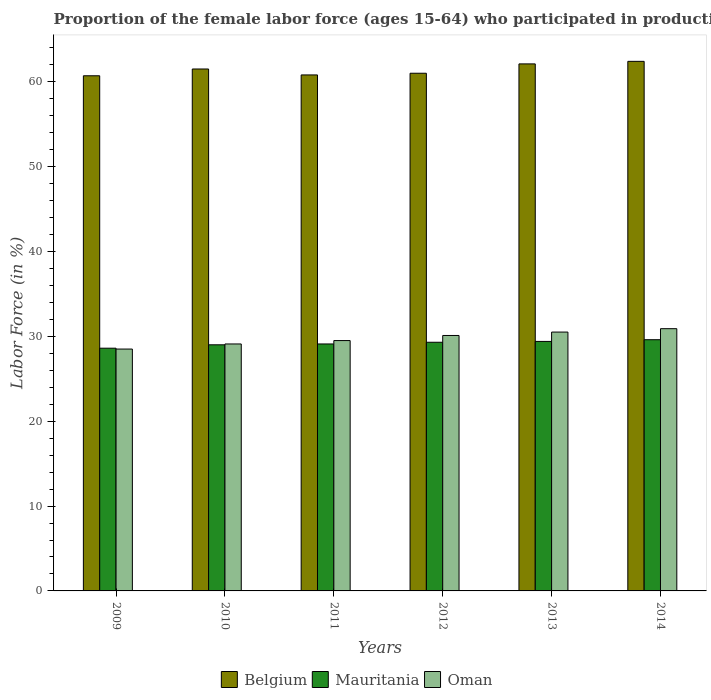How many bars are there on the 1st tick from the left?
Give a very brief answer. 3. What is the label of the 1st group of bars from the left?
Provide a short and direct response. 2009. What is the proportion of the female labor force who participated in production in Oman in 2011?
Give a very brief answer. 29.5. Across all years, what is the maximum proportion of the female labor force who participated in production in Oman?
Your answer should be very brief. 30.9. Across all years, what is the minimum proportion of the female labor force who participated in production in Belgium?
Provide a short and direct response. 60.7. What is the total proportion of the female labor force who participated in production in Oman in the graph?
Provide a succinct answer. 178.6. What is the difference between the proportion of the female labor force who participated in production in Oman in 2010 and the proportion of the female labor force who participated in production in Belgium in 2012?
Your response must be concise. -31.9. What is the average proportion of the female labor force who participated in production in Mauritania per year?
Give a very brief answer. 29.17. In the year 2010, what is the difference between the proportion of the female labor force who participated in production in Mauritania and proportion of the female labor force who participated in production in Belgium?
Ensure brevity in your answer.  -32.5. In how many years, is the proportion of the female labor force who participated in production in Belgium greater than 24 %?
Keep it short and to the point. 6. What is the ratio of the proportion of the female labor force who participated in production in Mauritania in 2010 to that in 2011?
Provide a short and direct response. 1. Is the proportion of the female labor force who participated in production in Belgium in 2009 less than that in 2014?
Your response must be concise. Yes. Is the difference between the proportion of the female labor force who participated in production in Mauritania in 2012 and 2013 greater than the difference between the proportion of the female labor force who participated in production in Belgium in 2012 and 2013?
Offer a terse response. Yes. What is the difference between the highest and the second highest proportion of the female labor force who participated in production in Belgium?
Provide a succinct answer. 0.3. What is the difference between the highest and the lowest proportion of the female labor force who participated in production in Belgium?
Your answer should be compact. 1.7. In how many years, is the proportion of the female labor force who participated in production in Belgium greater than the average proportion of the female labor force who participated in production in Belgium taken over all years?
Make the answer very short. 3. What does the 1st bar from the left in 2009 represents?
Ensure brevity in your answer.  Belgium. Are all the bars in the graph horizontal?
Your response must be concise. No. What is the difference between two consecutive major ticks on the Y-axis?
Offer a terse response. 10. Are the values on the major ticks of Y-axis written in scientific E-notation?
Your answer should be compact. No. Does the graph contain grids?
Ensure brevity in your answer.  No. Where does the legend appear in the graph?
Offer a very short reply. Bottom center. How many legend labels are there?
Offer a very short reply. 3. What is the title of the graph?
Your answer should be very brief. Proportion of the female labor force (ages 15-64) who participated in production. Does "East Asia (developing only)" appear as one of the legend labels in the graph?
Your answer should be very brief. No. What is the Labor Force (in %) of Belgium in 2009?
Your answer should be very brief. 60.7. What is the Labor Force (in %) in Mauritania in 2009?
Give a very brief answer. 28.6. What is the Labor Force (in %) in Belgium in 2010?
Provide a succinct answer. 61.5. What is the Labor Force (in %) of Oman in 2010?
Offer a terse response. 29.1. What is the Labor Force (in %) of Belgium in 2011?
Give a very brief answer. 60.8. What is the Labor Force (in %) of Mauritania in 2011?
Offer a terse response. 29.1. What is the Labor Force (in %) of Oman in 2011?
Provide a succinct answer. 29.5. What is the Labor Force (in %) of Belgium in 2012?
Your answer should be very brief. 61. What is the Labor Force (in %) of Mauritania in 2012?
Keep it short and to the point. 29.3. What is the Labor Force (in %) in Oman in 2012?
Provide a short and direct response. 30.1. What is the Labor Force (in %) in Belgium in 2013?
Make the answer very short. 62.1. What is the Labor Force (in %) in Mauritania in 2013?
Your response must be concise. 29.4. What is the Labor Force (in %) of Oman in 2013?
Offer a terse response. 30.5. What is the Labor Force (in %) in Belgium in 2014?
Your answer should be very brief. 62.4. What is the Labor Force (in %) of Mauritania in 2014?
Ensure brevity in your answer.  29.6. What is the Labor Force (in %) of Oman in 2014?
Your response must be concise. 30.9. Across all years, what is the maximum Labor Force (in %) in Belgium?
Your answer should be very brief. 62.4. Across all years, what is the maximum Labor Force (in %) in Mauritania?
Offer a very short reply. 29.6. Across all years, what is the maximum Labor Force (in %) in Oman?
Offer a terse response. 30.9. Across all years, what is the minimum Labor Force (in %) of Belgium?
Offer a very short reply. 60.7. Across all years, what is the minimum Labor Force (in %) in Mauritania?
Your response must be concise. 28.6. Across all years, what is the minimum Labor Force (in %) of Oman?
Offer a terse response. 28.5. What is the total Labor Force (in %) in Belgium in the graph?
Your answer should be compact. 368.5. What is the total Labor Force (in %) in Mauritania in the graph?
Make the answer very short. 175. What is the total Labor Force (in %) in Oman in the graph?
Give a very brief answer. 178.6. What is the difference between the Labor Force (in %) in Belgium in 2009 and that in 2010?
Provide a short and direct response. -0.8. What is the difference between the Labor Force (in %) of Oman in 2009 and that in 2010?
Your answer should be compact. -0.6. What is the difference between the Labor Force (in %) in Belgium in 2009 and that in 2011?
Offer a terse response. -0.1. What is the difference between the Labor Force (in %) in Mauritania in 2009 and that in 2011?
Provide a succinct answer. -0.5. What is the difference between the Labor Force (in %) of Belgium in 2009 and that in 2012?
Keep it short and to the point. -0.3. What is the difference between the Labor Force (in %) in Mauritania in 2009 and that in 2013?
Your answer should be very brief. -0.8. What is the difference between the Labor Force (in %) in Mauritania in 2009 and that in 2014?
Offer a terse response. -1. What is the difference between the Labor Force (in %) of Oman in 2009 and that in 2014?
Provide a short and direct response. -2.4. What is the difference between the Labor Force (in %) of Belgium in 2010 and that in 2012?
Make the answer very short. 0.5. What is the difference between the Labor Force (in %) of Mauritania in 2010 and that in 2012?
Offer a terse response. -0.3. What is the difference between the Labor Force (in %) of Oman in 2010 and that in 2012?
Ensure brevity in your answer.  -1. What is the difference between the Labor Force (in %) in Belgium in 2010 and that in 2013?
Make the answer very short. -0.6. What is the difference between the Labor Force (in %) in Mauritania in 2010 and that in 2013?
Give a very brief answer. -0.4. What is the difference between the Labor Force (in %) in Belgium in 2010 and that in 2014?
Give a very brief answer. -0.9. What is the difference between the Labor Force (in %) of Oman in 2010 and that in 2014?
Keep it short and to the point. -1.8. What is the difference between the Labor Force (in %) of Mauritania in 2011 and that in 2012?
Provide a succinct answer. -0.2. What is the difference between the Labor Force (in %) of Mauritania in 2011 and that in 2013?
Provide a succinct answer. -0.3. What is the difference between the Labor Force (in %) of Belgium in 2011 and that in 2014?
Make the answer very short. -1.6. What is the difference between the Labor Force (in %) of Mauritania in 2011 and that in 2014?
Keep it short and to the point. -0.5. What is the difference between the Labor Force (in %) in Oman in 2011 and that in 2014?
Your response must be concise. -1.4. What is the difference between the Labor Force (in %) of Belgium in 2012 and that in 2013?
Provide a succinct answer. -1.1. What is the difference between the Labor Force (in %) of Mauritania in 2012 and that in 2013?
Your answer should be compact. -0.1. What is the difference between the Labor Force (in %) in Mauritania in 2012 and that in 2014?
Provide a short and direct response. -0.3. What is the difference between the Labor Force (in %) of Oman in 2012 and that in 2014?
Ensure brevity in your answer.  -0.8. What is the difference between the Labor Force (in %) of Mauritania in 2013 and that in 2014?
Your answer should be compact. -0.2. What is the difference between the Labor Force (in %) in Oman in 2013 and that in 2014?
Offer a terse response. -0.4. What is the difference between the Labor Force (in %) of Belgium in 2009 and the Labor Force (in %) of Mauritania in 2010?
Give a very brief answer. 31.7. What is the difference between the Labor Force (in %) of Belgium in 2009 and the Labor Force (in %) of Oman in 2010?
Your answer should be compact. 31.6. What is the difference between the Labor Force (in %) in Mauritania in 2009 and the Labor Force (in %) in Oman in 2010?
Your answer should be compact. -0.5. What is the difference between the Labor Force (in %) of Belgium in 2009 and the Labor Force (in %) of Mauritania in 2011?
Your answer should be very brief. 31.6. What is the difference between the Labor Force (in %) of Belgium in 2009 and the Labor Force (in %) of Oman in 2011?
Ensure brevity in your answer.  31.2. What is the difference between the Labor Force (in %) of Mauritania in 2009 and the Labor Force (in %) of Oman in 2011?
Ensure brevity in your answer.  -0.9. What is the difference between the Labor Force (in %) of Belgium in 2009 and the Labor Force (in %) of Mauritania in 2012?
Offer a terse response. 31.4. What is the difference between the Labor Force (in %) in Belgium in 2009 and the Labor Force (in %) in Oman in 2012?
Your response must be concise. 30.6. What is the difference between the Labor Force (in %) of Belgium in 2009 and the Labor Force (in %) of Mauritania in 2013?
Offer a terse response. 31.3. What is the difference between the Labor Force (in %) in Belgium in 2009 and the Labor Force (in %) in Oman in 2013?
Make the answer very short. 30.2. What is the difference between the Labor Force (in %) in Belgium in 2009 and the Labor Force (in %) in Mauritania in 2014?
Offer a very short reply. 31.1. What is the difference between the Labor Force (in %) of Belgium in 2009 and the Labor Force (in %) of Oman in 2014?
Give a very brief answer. 29.8. What is the difference between the Labor Force (in %) in Mauritania in 2009 and the Labor Force (in %) in Oman in 2014?
Keep it short and to the point. -2.3. What is the difference between the Labor Force (in %) of Belgium in 2010 and the Labor Force (in %) of Mauritania in 2011?
Offer a terse response. 32.4. What is the difference between the Labor Force (in %) of Belgium in 2010 and the Labor Force (in %) of Mauritania in 2012?
Provide a succinct answer. 32.2. What is the difference between the Labor Force (in %) of Belgium in 2010 and the Labor Force (in %) of Oman in 2012?
Make the answer very short. 31.4. What is the difference between the Labor Force (in %) in Belgium in 2010 and the Labor Force (in %) in Mauritania in 2013?
Ensure brevity in your answer.  32.1. What is the difference between the Labor Force (in %) in Belgium in 2010 and the Labor Force (in %) in Mauritania in 2014?
Give a very brief answer. 31.9. What is the difference between the Labor Force (in %) in Belgium in 2010 and the Labor Force (in %) in Oman in 2014?
Your response must be concise. 30.6. What is the difference between the Labor Force (in %) of Belgium in 2011 and the Labor Force (in %) of Mauritania in 2012?
Your answer should be very brief. 31.5. What is the difference between the Labor Force (in %) of Belgium in 2011 and the Labor Force (in %) of Oman in 2012?
Offer a very short reply. 30.7. What is the difference between the Labor Force (in %) of Mauritania in 2011 and the Labor Force (in %) of Oman in 2012?
Keep it short and to the point. -1. What is the difference between the Labor Force (in %) in Belgium in 2011 and the Labor Force (in %) in Mauritania in 2013?
Keep it short and to the point. 31.4. What is the difference between the Labor Force (in %) in Belgium in 2011 and the Labor Force (in %) in Oman in 2013?
Make the answer very short. 30.3. What is the difference between the Labor Force (in %) in Belgium in 2011 and the Labor Force (in %) in Mauritania in 2014?
Offer a very short reply. 31.2. What is the difference between the Labor Force (in %) in Belgium in 2011 and the Labor Force (in %) in Oman in 2014?
Offer a terse response. 29.9. What is the difference between the Labor Force (in %) of Belgium in 2012 and the Labor Force (in %) of Mauritania in 2013?
Ensure brevity in your answer.  31.6. What is the difference between the Labor Force (in %) in Belgium in 2012 and the Labor Force (in %) in Oman in 2013?
Give a very brief answer. 30.5. What is the difference between the Labor Force (in %) in Belgium in 2012 and the Labor Force (in %) in Mauritania in 2014?
Offer a very short reply. 31.4. What is the difference between the Labor Force (in %) in Belgium in 2012 and the Labor Force (in %) in Oman in 2014?
Your answer should be very brief. 30.1. What is the difference between the Labor Force (in %) of Mauritania in 2012 and the Labor Force (in %) of Oman in 2014?
Ensure brevity in your answer.  -1.6. What is the difference between the Labor Force (in %) of Belgium in 2013 and the Labor Force (in %) of Mauritania in 2014?
Offer a very short reply. 32.5. What is the difference between the Labor Force (in %) of Belgium in 2013 and the Labor Force (in %) of Oman in 2014?
Offer a terse response. 31.2. What is the average Labor Force (in %) in Belgium per year?
Your response must be concise. 61.42. What is the average Labor Force (in %) of Mauritania per year?
Your answer should be compact. 29.17. What is the average Labor Force (in %) of Oman per year?
Offer a terse response. 29.77. In the year 2009, what is the difference between the Labor Force (in %) in Belgium and Labor Force (in %) in Mauritania?
Your answer should be compact. 32.1. In the year 2009, what is the difference between the Labor Force (in %) in Belgium and Labor Force (in %) in Oman?
Make the answer very short. 32.2. In the year 2009, what is the difference between the Labor Force (in %) of Mauritania and Labor Force (in %) of Oman?
Your response must be concise. 0.1. In the year 2010, what is the difference between the Labor Force (in %) in Belgium and Labor Force (in %) in Mauritania?
Your answer should be compact. 32.5. In the year 2010, what is the difference between the Labor Force (in %) of Belgium and Labor Force (in %) of Oman?
Give a very brief answer. 32.4. In the year 2010, what is the difference between the Labor Force (in %) in Mauritania and Labor Force (in %) in Oman?
Provide a short and direct response. -0.1. In the year 2011, what is the difference between the Labor Force (in %) of Belgium and Labor Force (in %) of Mauritania?
Your response must be concise. 31.7. In the year 2011, what is the difference between the Labor Force (in %) of Belgium and Labor Force (in %) of Oman?
Your answer should be very brief. 31.3. In the year 2012, what is the difference between the Labor Force (in %) of Belgium and Labor Force (in %) of Mauritania?
Keep it short and to the point. 31.7. In the year 2012, what is the difference between the Labor Force (in %) in Belgium and Labor Force (in %) in Oman?
Your answer should be compact. 30.9. In the year 2012, what is the difference between the Labor Force (in %) in Mauritania and Labor Force (in %) in Oman?
Offer a very short reply. -0.8. In the year 2013, what is the difference between the Labor Force (in %) in Belgium and Labor Force (in %) in Mauritania?
Your answer should be very brief. 32.7. In the year 2013, what is the difference between the Labor Force (in %) in Belgium and Labor Force (in %) in Oman?
Your response must be concise. 31.6. In the year 2014, what is the difference between the Labor Force (in %) in Belgium and Labor Force (in %) in Mauritania?
Make the answer very short. 32.8. In the year 2014, what is the difference between the Labor Force (in %) of Belgium and Labor Force (in %) of Oman?
Provide a short and direct response. 31.5. What is the ratio of the Labor Force (in %) of Belgium in 2009 to that in 2010?
Your response must be concise. 0.99. What is the ratio of the Labor Force (in %) of Mauritania in 2009 to that in 2010?
Give a very brief answer. 0.99. What is the ratio of the Labor Force (in %) in Oman in 2009 to that in 2010?
Offer a very short reply. 0.98. What is the ratio of the Labor Force (in %) of Mauritania in 2009 to that in 2011?
Ensure brevity in your answer.  0.98. What is the ratio of the Labor Force (in %) in Oman in 2009 to that in 2011?
Provide a succinct answer. 0.97. What is the ratio of the Labor Force (in %) in Mauritania in 2009 to that in 2012?
Your response must be concise. 0.98. What is the ratio of the Labor Force (in %) in Oman in 2009 to that in 2012?
Offer a very short reply. 0.95. What is the ratio of the Labor Force (in %) of Belgium in 2009 to that in 2013?
Your answer should be very brief. 0.98. What is the ratio of the Labor Force (in %) of Mauritania in 2009 to that in 2013?
Give a very brief answer. 0.97. What is the ratio of the Labor Force (in %) of Oman in 2009 to that in 2013?
Your answer should be very brief. 0.93. What is the ratio of the Labor Force (in %) in Belgium in 2009 to that in 2014?
Give a very brief answer. 0.97. What is the ratio of the Labor Force (in %) in Mauritania in 2009 to that in 2014?
Your answer should be compact. 0.97. What is the ratio of the Labor Force (in %) of Oman in 2009 to that in 2014?
Your response must be concise. 0.92. What is the ratio of the Labor Force (in %) in Belgium in 2010 to that in 2011?
Your response must be concise. 1.01. What is the ratio of the Labor Force (in %) of Mauritania in 2010 to that in 2011?
Your response must be concise. 1. What is the ratio of the Labor Force (in %) of Oman in 2010 to that in 2011?
Your answer should be very brief. 0.99. What is the ratio of the Labor Force (in %) in Belgium in 2010 to that in 2012?
Provide a succinct answer. 1.01. What is the ratio of the Labor Force (in %) in Mauritania in 2010 to that in 2012?
Offer a very short reply. 0.99. What is the ratio of the Labor Force (in %) in Oman in 2010 to that in 2012?
Keep it short and to the point. 0.97. What is the ratio of the Labor Force (in %) of Belgium in 2010 to that in 2013?
Provide a short and direct response. 0.99. What is the ratio of the Labor Force (in %) of Mauritania in 2010 to that in 2013?
Your response must be concise. 0.99. What is the ratio of the Labor Force (in %) in Oman in 2010 to that in 2013?
Offer a very short reply. 0.95. What is the ratio of the Labor Force (in %) of Belgium in 2010 to that in 2014?
Your response must be concise. 0.99. What is the ratio of the Labor Force (in %) in Mauritania in 2010 to that in 2014?
Give a very brief answer. 0.98. What is the ratio of the Labor Force (in %) of Oman in 2010 to that in 2014?
Offer a very short reply. 0.94. What is the ratio of the Labor Force (in %) of Oman in 2011 to that in 2012?
Provide a short and direct response. 0.98. What is the ratio of the Labor Force (in %) in Belgium in 2011 to that in 2013?
Provide a short and direct response. 0.98. What is the ratio of the Labor Force (in %) of Mauritania in 2011 to that in 2013?
Offer a very short reply. 0.99. What is the ratio of the Labor Force (in %) of Oman in 2011 to that in 2013?
Provide a short and direct response. 0.97. What is the ratio of the Labor Force (in %) in Belgium in 2011 to that in 2014?
Make the answer very short. 0.97. What is the ratio of the Labor Force (in %) of Mauritania in 2011 to that in 2014?
Give a very brief answer. 0.98. What is the ratio of the Labor Force (in %) in Oman in 2011 to that in 2014?
Provide a succinct answer. 0.95. What is the ratio of the Labor Force (in %) in Belgium in 2012 to that in 2013?
Provide a short and direct response. 0.98. What is the ratio of the Labor Force (in %) in Oman in 2012 to that in 2013?
Offer a terse response. 0.99. What is the ratio of the Labor Force (in %) of Belgium in 2012 to that in 2014?
Give a very brief answer. 0.98. What is the ratio of the Labor Force (in %) of Oman in 2012 to that in 2014?
Your response must be concise. 0.97. What is the ratio of the Labor Force (in %) of Mauritania in 2013 to that in 2014?
Your answer should be compact. 0.99. What is the ratio of the Labor Force (in %) of Oman in 2013 to that in 2014?
Your answer should be very brief. 0.99. What is the difference between the highest and the second highest Labor Force (in %) of Belgium?
Your answer should be very brief. 0.3. What is the difference between the highest and the second highest Labor Force (in %) in Mauritania?
Your response must be concise. 0.2. What is the difference between the highest and the second highest Labor Force (in %) of Oman?
Ensure brevity in your answer.  0.4. What is the difference between the highest and the lowest Labor Force (in %) in Belgium?
Provide a short and direct response. 1.7. 